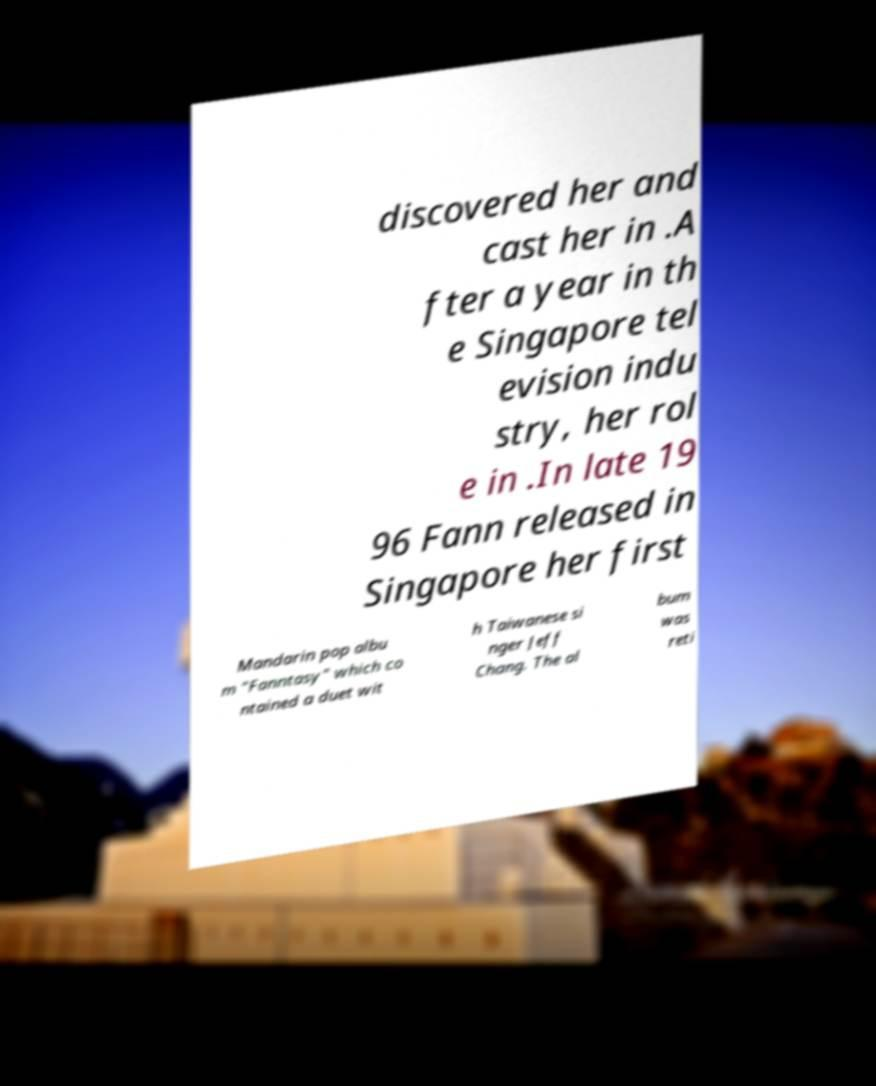Please identify and transcribe the text found in this image. discovered her and cast her in .A fter a year in th e Singapore tel evision indu stry, her rol e in .In late 19 96 Fann released in Singapore her first Mandarin pop albu m "Fanntasy" which co ntained a duet wit h Taiwanese si nger Jeff Chang. The al bum was reti 